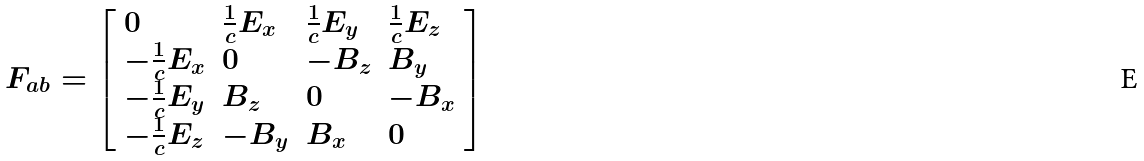<formula> <loc_0><loc_0><loc_500><loc_500>F _ { a b } = { \left [ \begin{array} { l l l l } { 0 } & { { \frac { 1 } { c } } E _ { x } } & { { \frac { 1 } { c } } E _ { y } } & { { \frac { 1 } { c } } E _ { z } } \\ { - { \frac { 1 } { c } } E _ { x } } & { 0 } & { - B _ { z } } & { B _ { y } } \\ { - { \frac { 1 } { c } } E _ { y } } & { B _ { z } } & { 0 } & { - B _ { x } } \\ { - { \frac { 1 } { c } } E _ { z } } & { - B _ { y } } & { B _ { x } } & { 0 } \end{array} \right ] }</formula> 